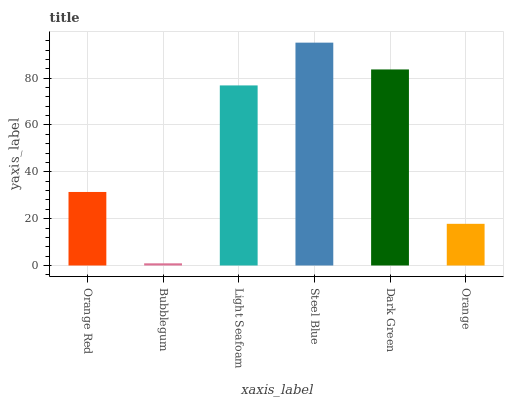Is Bubblegum the minimum?
Answer yes or no. Yes. Is Steel Blue the maximum?
Answer yes or no. Yes. Is Light Seafoam the minimum?
Answer yes or no. No. Is Light Seafoam the maximum?
Answer yes or no. No. Is Light Seafoam greater than Bubblegum?
Answer yes or no. Yes. Is Bubblegum less than Light Seafoam?
Answer yes or no. Yes. Is Bubblegum greater than Light Seafoam?
Answer yes or no. No. Is Light Seafoam less than Bubblegum?
Answer yes or no. No. Is Light Seafoam the high median?
Answer yes or no. Yes. Is Orange Red the low median?
Answer yes or no. Yes. Is Steel Blue the high median?
Answer yes or no. No. Is Orange the low median?
Answer yes or no. No. 